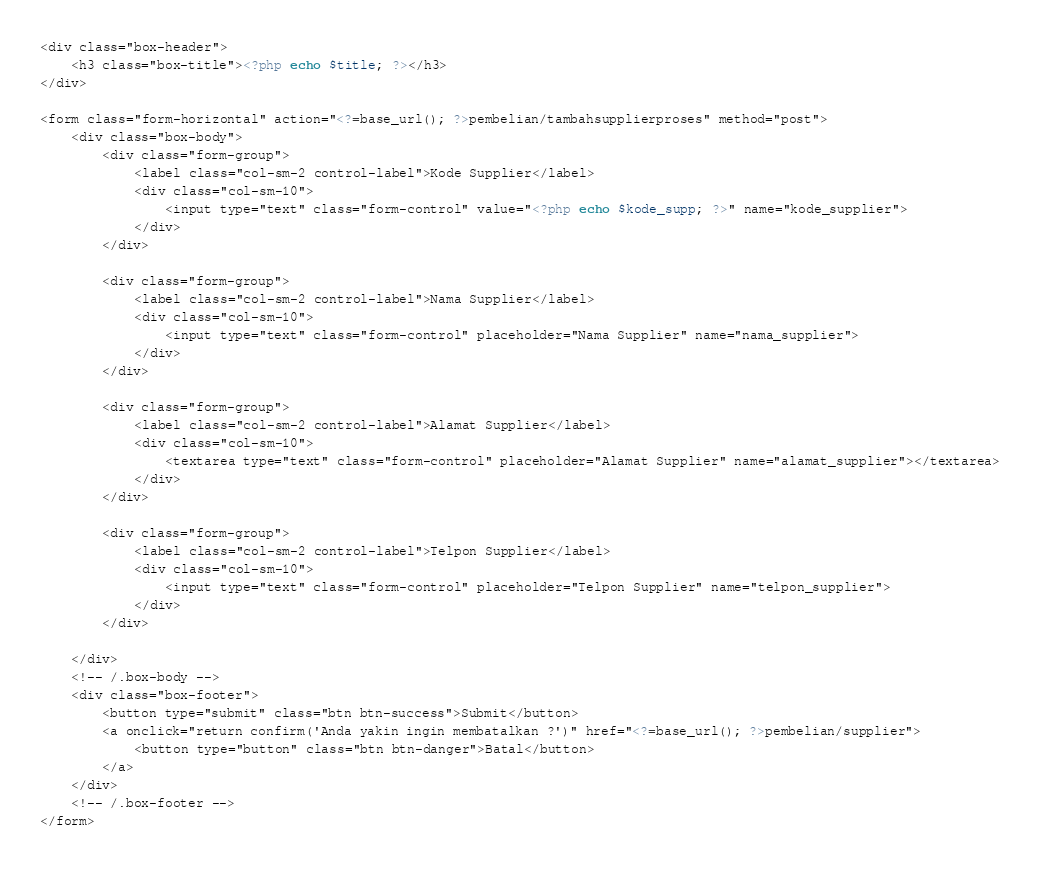Convert code to text. <code><loc_0><loc_0><loc_500><loc_500><_PHP_><div class="box-header">
    <h3 class="box-title"><?php echo $title; ?></h3>
</div>

<form class="form-horizontal" action="<?=base_url(); ?>pembelian/tambahsupplierproses" method="post">
    <div class="box-body">
        <div class="form-group">
            <label class="col-sm-2 control-label">Kode Supplier</label>
            <div class="col-sm-10">
                <input type="text" class="form-control" value="<?php echo $kode_supp; ?>" name="kode_supplier">
            </div>
        </div>

        <div class="form-group">
            <label class="col-sm-2 control-label">Nama Supplier</label>
            <div class="col-sm-10">
                <input type="text" class="form-control" placeholder="Nama Supplier" name="nama_supplier">
            </div>
        </div>

        <div class="form-group">
            <label class="col-sm-2 control-label">Alamat Supplier</label>
            <div class="col-sm-10">
                <textarea type="text" class="form-control" placeholder="Alamat Supplier" name="alamat_supplier"></textarea>
            </div>
        </div>

        <div class="form-group">
            <label class="col-sm-2 control-label">Telpon Supplier</label>
            <div class="col-sm-10">
                <input type="text" class="form-control" placeholder="Telpon Supplier" name="telpon_supplier">
            </div>
        </div>

    </div>
    <!-- /.box-body -->
    <div class="box-footer">
        <button type="submit" class="btn btn-success">Submit</button>
        <a onclick="return confirm('Anda yakin ingin membatalkan ?')" href="<?=base_url(); ?>pembelian/supplier">
            <button type="button" class="btn btn-danger">Batal</button>
        </a>
    </div>
    <!-- /.box-footer -->
</form></code> 